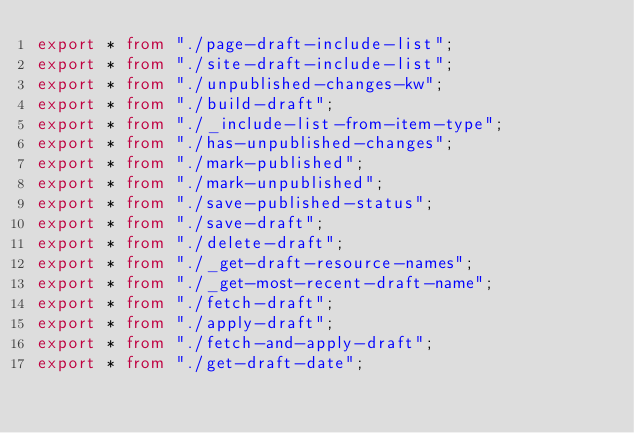<code> <loc_0><loc_0><loc_500><loc_500><_TypeScript_>export * from "./page-draft-include-list";
export * from "./site-draft-include-list";
export * from "./unpublished-changes-kw";
export * from "./build-draft";
export * from "./_include-list-from-item-type";
export * from "./has-unpublished-changes";
export * from "./mark-published";
export * from "./mark-unpublished";
export * from "./save-published-status";
export * from "./save-draft";
export * from "./delete-draft";
export * from "./_get-draft-resource-names";
export * from "./_get-most-recent-draft-name";
export * from "./fetch-draft";
export * from "./apply-draft";
export * from "./fetch-and-apply-draft";
export * from "./get-draft-date";
</code> 